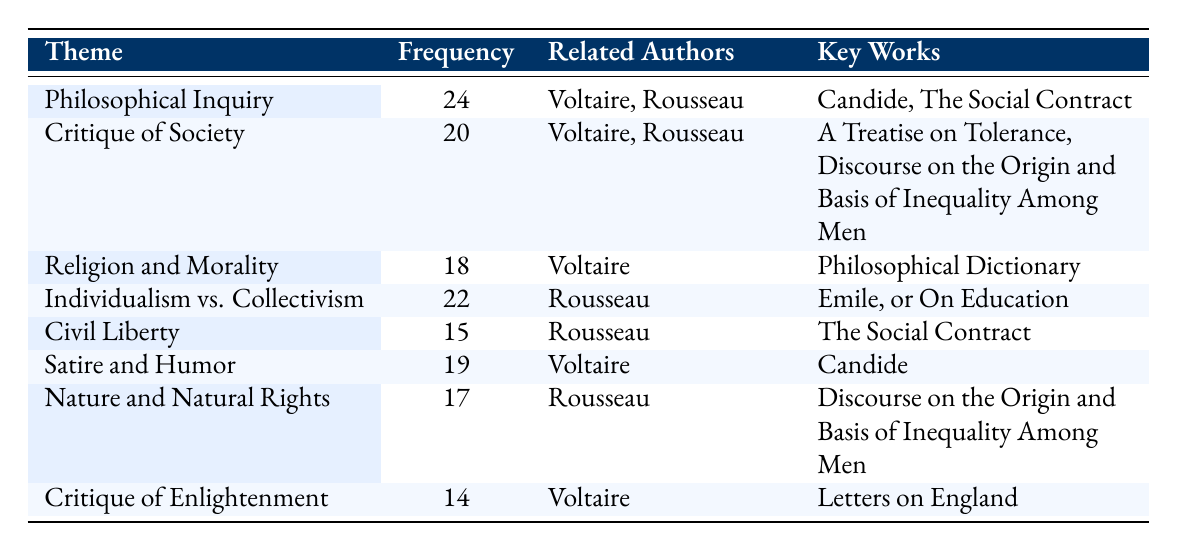What is the theme with the highest frequency? The table lists the themes in order of frequency. The first theme is "Philosophical Inquiry" with a frequency of 24, which is the highest value in the table.
Answer: Philosophical Inquiry How many themes are associated with Rousseau? By examining the "Related Authors" column, we see that Rousseau appears in four different themes: "Individualism vs. Collectivism," "Civil Liberty," "Philosophical Inquiry," and "Critique of Society."
Answer: Four What is the difference in frequency between "Satire and Humor" and "Critique of Enlightenment"? The frequency of "Satire and Humor" is 19 and the frequency of "Critique of Enlightenment" is 14. The difference is 19 minus 14, which equals 5.
Answer: 5 Is there a theme that solely relates to Voltaire without Rousseau? Looking through the "Related Authors" column, we find that "Religion and Morality," "Satire and Humor," and "Critique of Enlightenment" are themes attributed only to Voltaire. Therefore, the answer is yes.
Answer: Yes What is the average frequency of all the themes listed in the table? We first sum up all the frequencies: 24 + 20 + 18 + 22 + 15 + 19 + 17 + 14 =  149. There are 8 themes in total, so the average frequency is 149 divided by 8, which is approximately 18.625.
Answer: 18.625 Which themes are discussed in classes focused only on Rousseau? The column "Related Authors" indicates that the themes solely related to Rousseau are "Individualism vs. Collectivism," "Civil Liberty," and "Nature and Natural Rights." These three themes do not mention Voltaire.
Answer: Individualism vs. Collectivism, Civil Liberty, Nature and Natural Rights What theme has the lowest frequency and what is its frequency? The theme with the lowest frequency can be found by looking at the frequency numbers in the table. The "Critique of Enlightenment" has the lowest frequency at 14.
Answer: Critique of Enlightenment, 14 Which key work is associated with the theme "Critique of Society"? The table specifies that the key works related to "Critique of Society" are "A Treatise on Tolerance" and "Discourse on the Origin and Basis of Inequality Among Men."
Answer: A Treatise on Tolerance, Discourse on the Origin and Basis of Inequality Among Men 